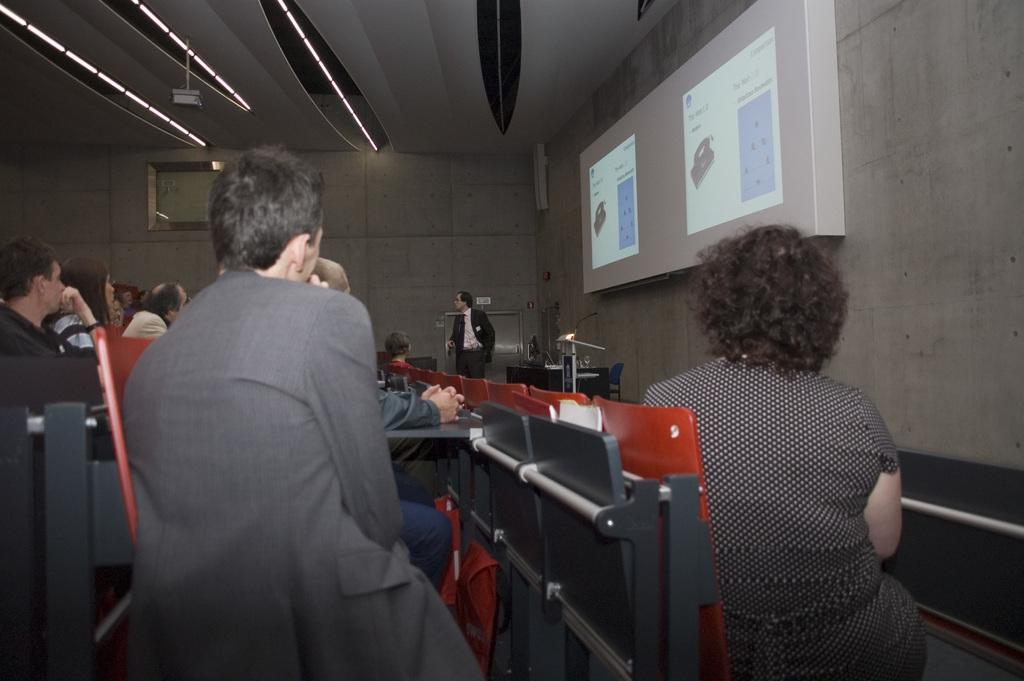In one or two sentences, can you explain what this image depicts? In the picture I can see some group of people sitting on chairs in a closed auditorium, in the background of the picture there is a person wearing black color suit standing, on right side of the picture there is projector screen and top of the picture there is projector, roof and lights. 